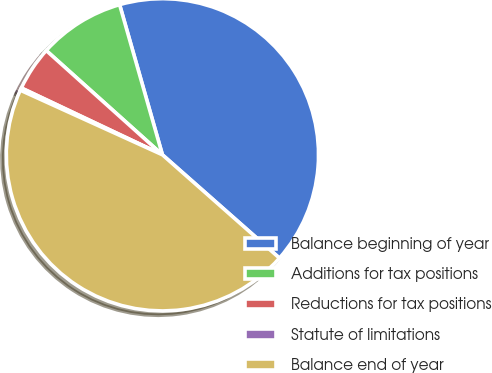Convert chart to OTSL. <chart><loc_0><loc_0><loc_500><loc_500><pie_chart><fcel>Balance beginning of year<fcel>Additions for tax positions<fcel>Reductions for tax positions<fcel>Statute of limitations<fcel>Balance end of year<nl><fcel>40.93%<fcel>8.94%<fcel>4.6%<fcel>0.25%<fcel>45.28%<nl></chart> 